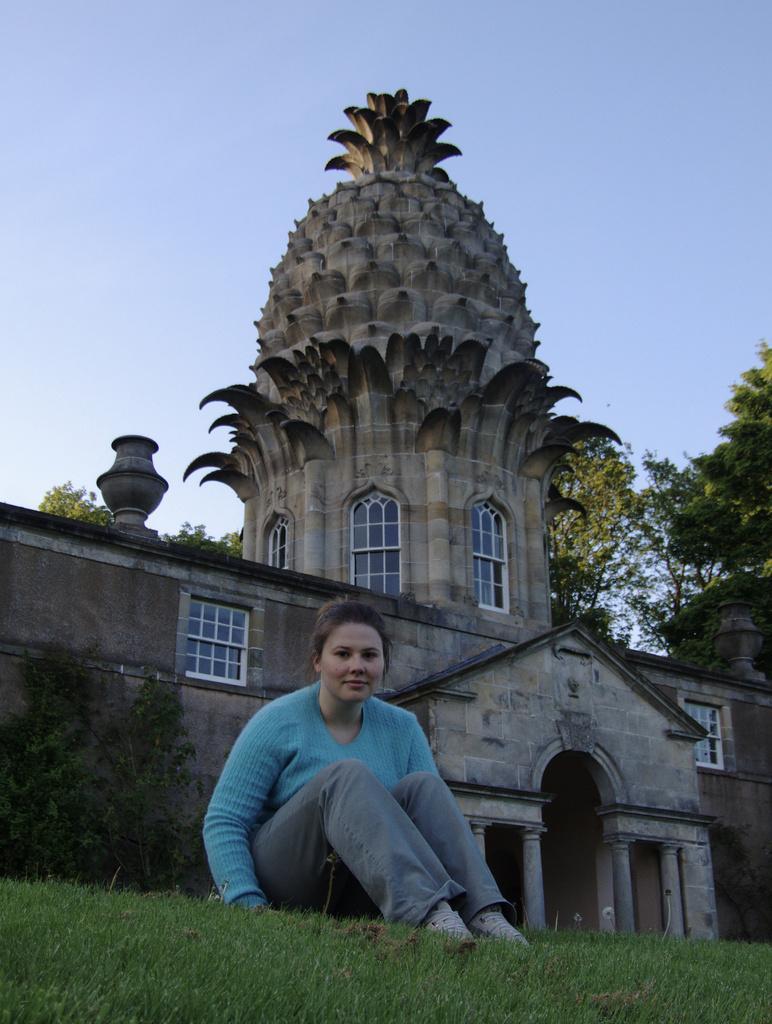In one or two sentences, can you explain what this image depicts? This picture is clicked outside. In the foreground there is a person wearing blue color t-shirt and sitting on the ground, the ground is covered with the green grass and we can see the plant and a building and we can see the windows of the building. In the background there is a sky and we can see trees. 